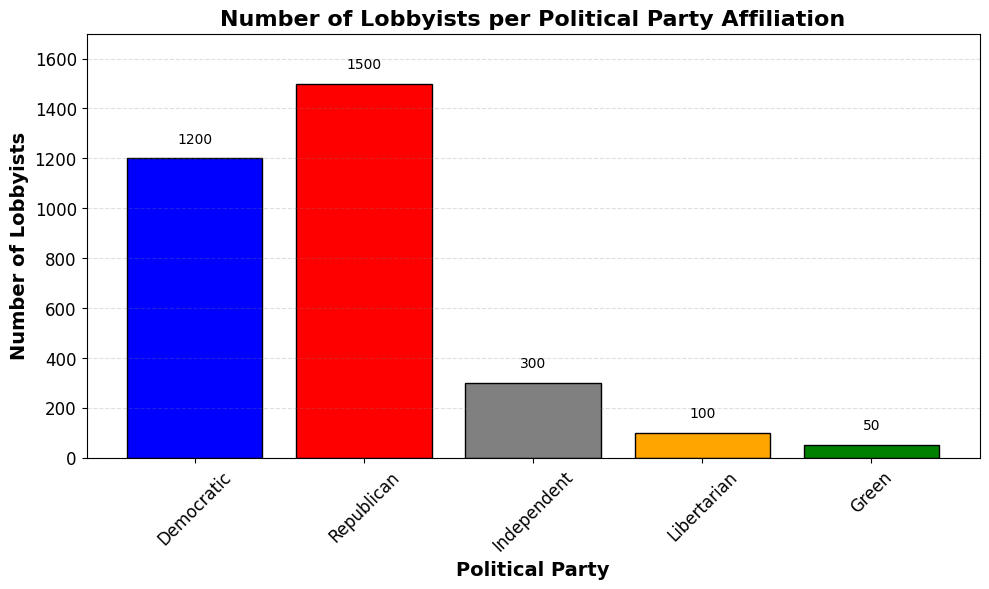What is the total number of lobbyists across all political party affiliations? To find the total, sum all the number of lobbyists: 1200 (Democratic) + 1500 (Republican) + 300 (Independent) + 100 (Libertarian) + 50 (Green) = 3150
Answer: 3150 Which political party has the highest number of lobbyists? The highest bar represents the Republican party with 1500 lobbyists.
Answer: Republican How many more lobbyists does the Republican party have compared to the Democratic party? The Republican party has 1500 lobbyists, and the Democratic party has 1200. The difference is 1500 - 1200 = 300
Answer: 300 What is the combined number of lobbyists for Independent, Libertarian, and Green parties? Sum the number of lobbyists for the Independent (300), Libertarian (100), and Green (50) parties: 300 + 100 + 50 = 450
Answer: 450 What is the average number of lobbyists per political party? There are 5 political parties with the following number of lobbyists: 1200, 1500, 300, 100, 50. The total is 3150. The average is calculated by dividing the total by the number of parties: 3150 / 5 = 630
Answer: 630 How does the height of the bar for the Libertarian party compare visually to the Green party? The Libertarian bar is approximately twice as high as the Green party bar, with 100 lobbyists compared to 50.
Answer: Twice as high Which political party has the fewest number of lobbyists? The smallest bar represents the Green party with 50 lobbyists.
Answer: Green Is the number of lobbyists for the Independent party greater than the combined number for the Libertarian and Green parties? The Independent party has 300 lobbyists, while the combined number for the Libertarian and Green parties is 100 + 50 = 150. Since 300 > 150, the statement is true.
Answer: Yes 